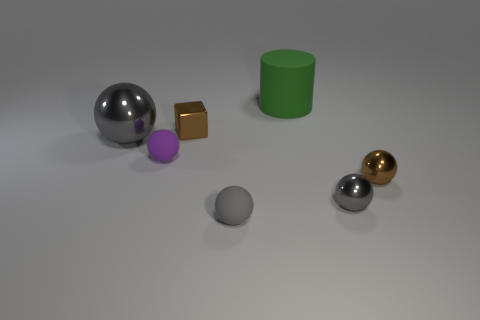Subtract all metallic balls. How many balls are left? 2 Subtract all brown spheres. How many spheres are left? 4 Subtract all gray blocks. How many gray spheres are left? 3 Add 1 red rubber things. How many objects exist? 8 Subtract all cylinders. How many objects are left? 6 Subtract 5 spheres. How many spheres are left? 0 Add 6 tiny brown shiny balls. How many tiny brown shiny balls are left? 7 Add 2 large gray shiny spheres. How many large gray shiny spheres exist? 3 Subtract 0 gray cylinders. How many objects are left? 7 Subtract all yellow cylinders. Subtract all cyan spheres. How many cylinders are left? 1 